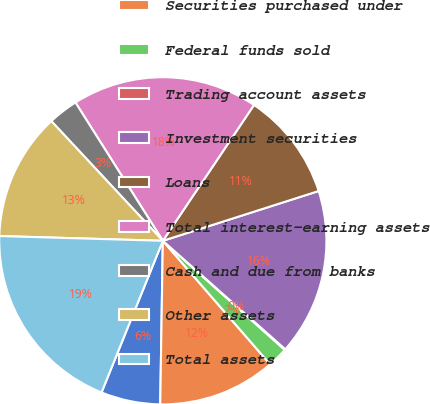Convert chart to OTSL. <chart><loc_0><loc_0><loc_500><loc_500><pie_chart><fcel>Interest-bearing deposits with<fcel>Securities purchased under<fcel>Federal funds sold<fcel>Trading account assets<fcel>Investment securities<fcel>Loans<fcel>Total interest-earning assets<fcel>Cash and due from banks<fcel>Other assets<fcel>Total assets<nl><fcel>5.86%<fcel>11.64%<fcel>2.0%<fcel>0.08%<fcel>16.46%<fcel>10.67%<fcel>18.38%<fcel>2.97%<fcel>12.6%<fcel>19.35%<nl></chart> 